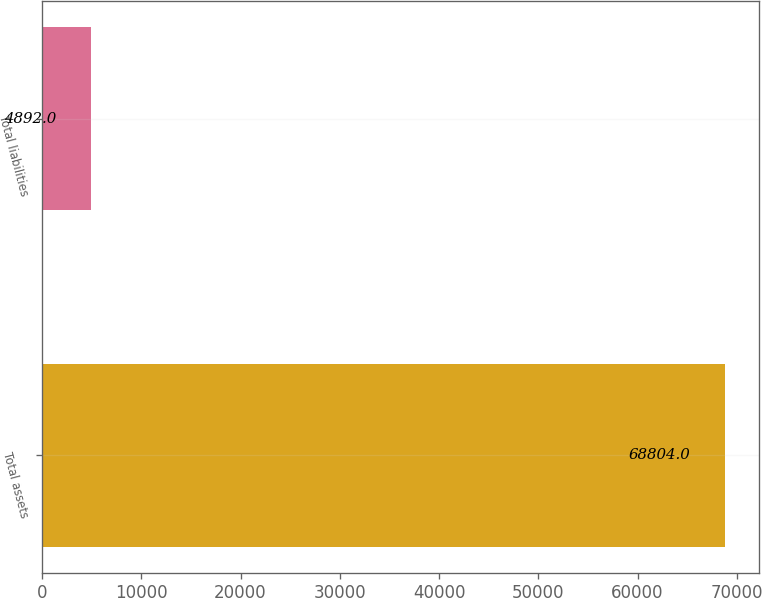Convert chart. <chart><loc_0><loc_0><loc_500><loc_500><bar_chart><fcel>Total assets<fcel>Total liabilities<nl><fcel>68804<fcel>4892<nl></chart> 